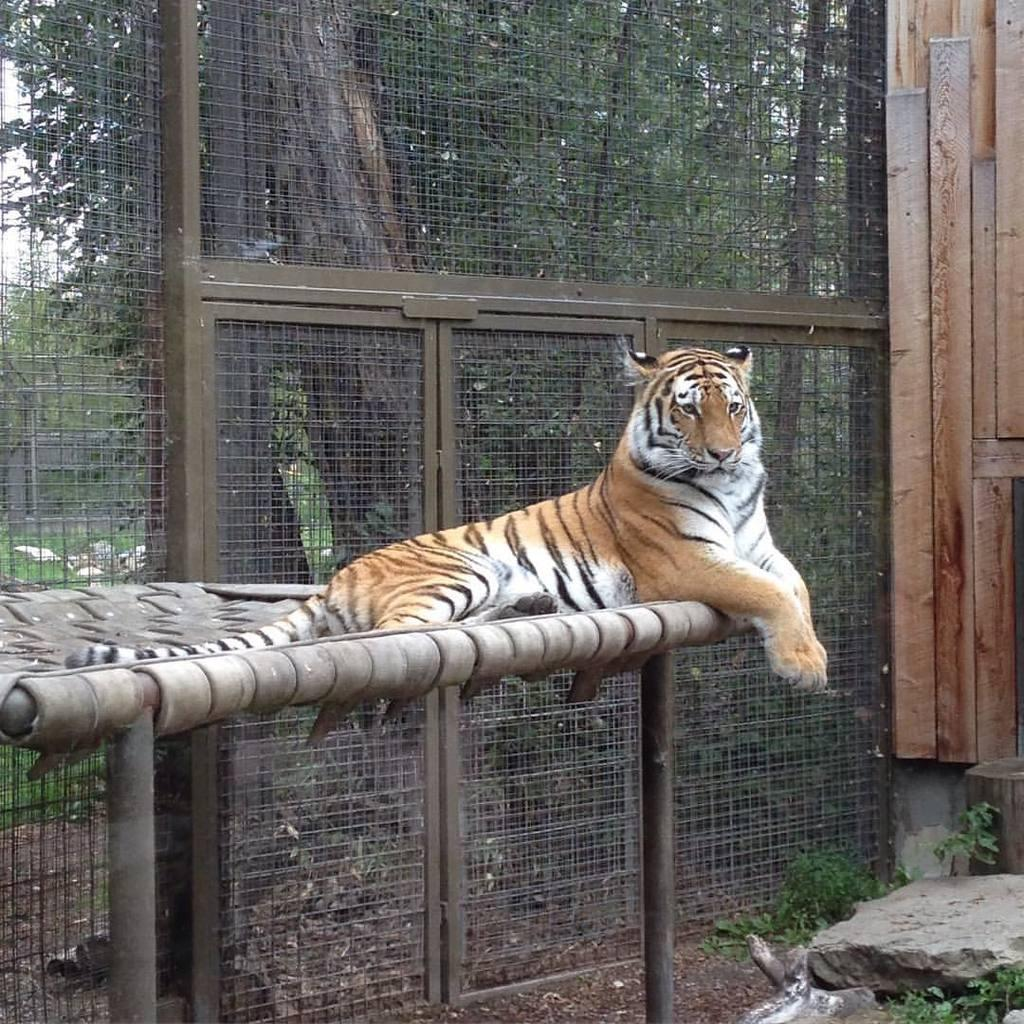What animal is sitting on a platform in the image? There is a tiger sitting on a platform in the image. What type of structures can be seen in the image? There are poles, welded wire mesh, metal doors, and a wooden object visible in the image. What type of natural elements can be seen in the image? There are trees, plants, and a stone visible in the image. What is visible in the background of the image? The sky is visible in the image. What type of advertisement can be seen on the tiger's back in the image? There is no advertisement present on the tiger's back in the image. What type of pipe is visible in the image? There is no pipe visible in the image. 